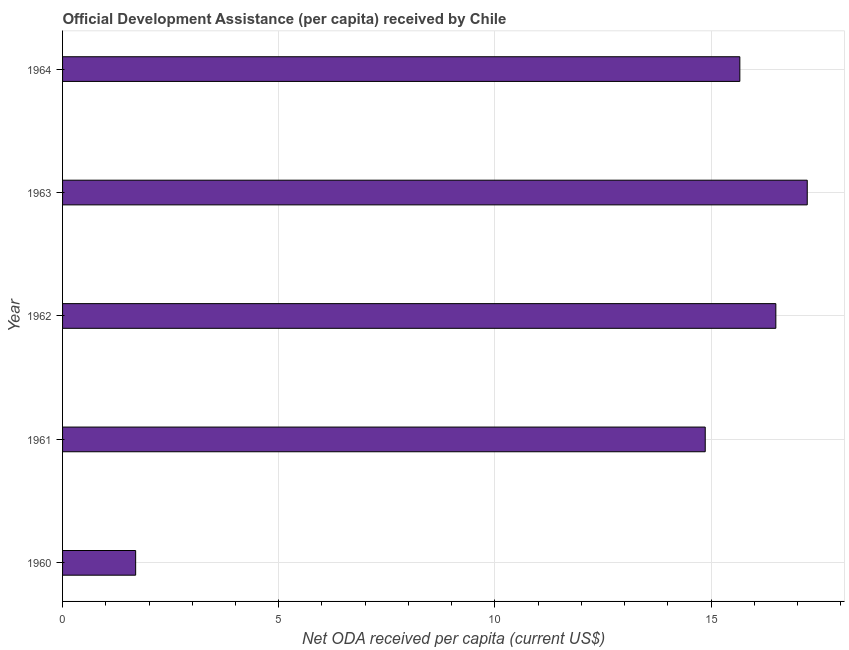Does the graph contain grids?
Your answer should be compact. Yes. What is the title of the graph?
Make the answer very short. Official Development Assistance (per capita) received by Chile. What is the label or title of the X-axis?
Ensure brevity in your answer.  Net ODA received per capita (current US$). What is the label or title of the Y-axis?
Provide a short and direct response. Year. What is the net oda received per capita in 1960?
Offer a terse response. 1.69. Across all years, what is the maximum net oda received per capita?
Offer a terse response. 17.22. Across all years, what is the minimum net oda received per capita?
Your answer should be compact. 1.69. What is the sum of the net oda received per capita?
Provide a succinct answer. 65.94. What is the difference between the net oda received per capita in 1962 and 1964?
Provide a short and direct response. 0.83. What is the average net oda received per capita per year?
Give a very brief answer. 13.19. What is the median net oda received per capita?
Keep it short and to the point. 15.67. In how many years, is the net oda received per capita greater than 5 US$?
Your answer should be very brief. 4. Do a majority of the years between 1964 and 1962 (inclusive) have net oda received per capita greater than 8 US$?
Offer a terse response. Yes. What is the ratio of the net oda received per capita in 1962 to that in 1963?
Offer a very short reply. 0.96. Is the difference between the net oda received per capita in 1961 and 1963 greater than the difference between any two years?
Your answer should be very brief. No. What is the difference between the highest and the second highest net oda received per capita?
Your answer should be compact. 0.73. What is the difference between the highest and the lowest net oda received per capita?
Your response must be concise. 15.53. In how many years, is the net oda received per capita greater than the average net oda received per capita taken over all years?
Make the answer very short. 4. Are the values on the major ticks of X-axis written in scientific E-notation?
Your response must be concise. No. What is the Net ODA received per capita (current US$) in 1960?
Keep it short and to the point. 1.69. What is the Net ODA received per capita (current US$) of 1961?
Offer a terse response. 14.87. What is the Net ODA received per capita (current US$) in 1962?
Provide a short and direct response. 16.5. What is the Net ODA received per capita (current US$) of 1963?
Give a very brief answer. 17.22. What is the Net ODA received per capita (current US$) of 1964?
Ensure brevity in your answer.  15.67. What is the difference between the Net ODA received per capita (current US$) in 1960 and 1961?
Ensure brevity in your answer.  -13.17. What is the difference between the Net ODA received per capita (current US$) in 1960 and 1962?
Provide a succinct answer. -14.81. What is the difference between the Net ODA received per capita (current US$) in 1960 and 1963?
Keep it short and to the point. -15.53. What is the difference between the Net ODA received per capita (current US$) in 1960 and 1964?
Offer a terse response. -13.97. What is the difference between the Net ODA received per capita (current US$) in 1961 and 1962?
Your answer should be very brief. -1.63. What is the difference between the Net ODA received per capita (current US$) in 1961 and 1963?
Keep it short and to the point. -2.36. What is the difference between the Net ODA received per capita (current US$) in 1961 and 1964?
Ensure brevity in your answer.  -0.8. What is the difference between the Net ODA received per capita (current US$) in 1962 and 1963?
Offer a terse response. -0.73. What is the difference between the Net ODA received per capita (current US$) in 1962 and 1964?
Make the answer very short. 0.83. What is the difference between the Net ODA received per capita (current US$) in 1963 and 1964?
Keep it short and to the point. 1.56. What is the ratio of the Net ODA received per capita (current US$) in 1960 to that in 1961?
Provide a succinct answer. 0.11. What is the ratio of the Net ODA received per capita (current US$) in 1960 to that in 1962?
Your answer should be compact. 0.1. What is the ratio of the Net ODA received per capita (current US$) in 1960 to that in 1963?
Provide a succinct answer. 0.1. What is the ratio of the Net ODA received per capita (current US$) in 1960 to that in 1964?
Provide a short and direct response. 0.11. What is the ratio of the Net ODA received per capita (current US$) in 1961 to that in 1962?
Provide a succinct answer. 0.9. What is the ratio of the Net ODA received per capita (current US$) in 1961 to that in 1963?
Ensure brevity in your answer.  0.86. What is the ratio of the Net ODA received per capita (current US$) in 1961 to that in 1964?
Offer a very short reply. 0.95. What is the ratio of the Net ODA received per capita (current US$) in 1962 to that in 1963?
Your answer should be compact. 0.96. What is the ratio of the Net ODA received per capita (current US$) in 1962 to that in 1964?
Give a very brief answer. 1.05. 